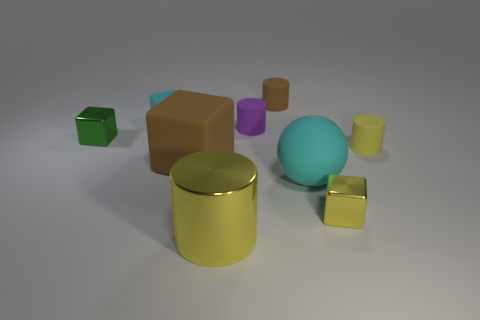How big is the green metal block?
Offer a terse response. Small. What number of other things are there of the same size as the rubber ball?
Give a very brief answer. 2. What is the size of the cylinder that is in front of the big thing right of the big yellow cylinder?
Your response must be concise. Large. What number of big things are either brown balls or metal objects?
Give a very brief answer. 1. What size is the yellow cylinder in front of the rubber ball that is in front of the brown object behind the purple cylinder?
Your answer should be compact. Large. Is there anything else of the same color as the large shiny cylinder?
Your answer should be compact. Yes. There is a tiny yellow thing to the right of the metal cube on the right side of the small metal block left of the small purple object; what is its material?
Offer a terse response. Rubber. Is the small green shiny thing the same shape as the tiny yellow metallic object?
Give a very brief answer. Yes. Is there anything else that has the same material as the tiny yellow cylinder?
Your answer should be compact. Yes. How many rubber objects are to the left of the large cylinder and in front of the small green shiny cube?
Offer a terse response. 1. 